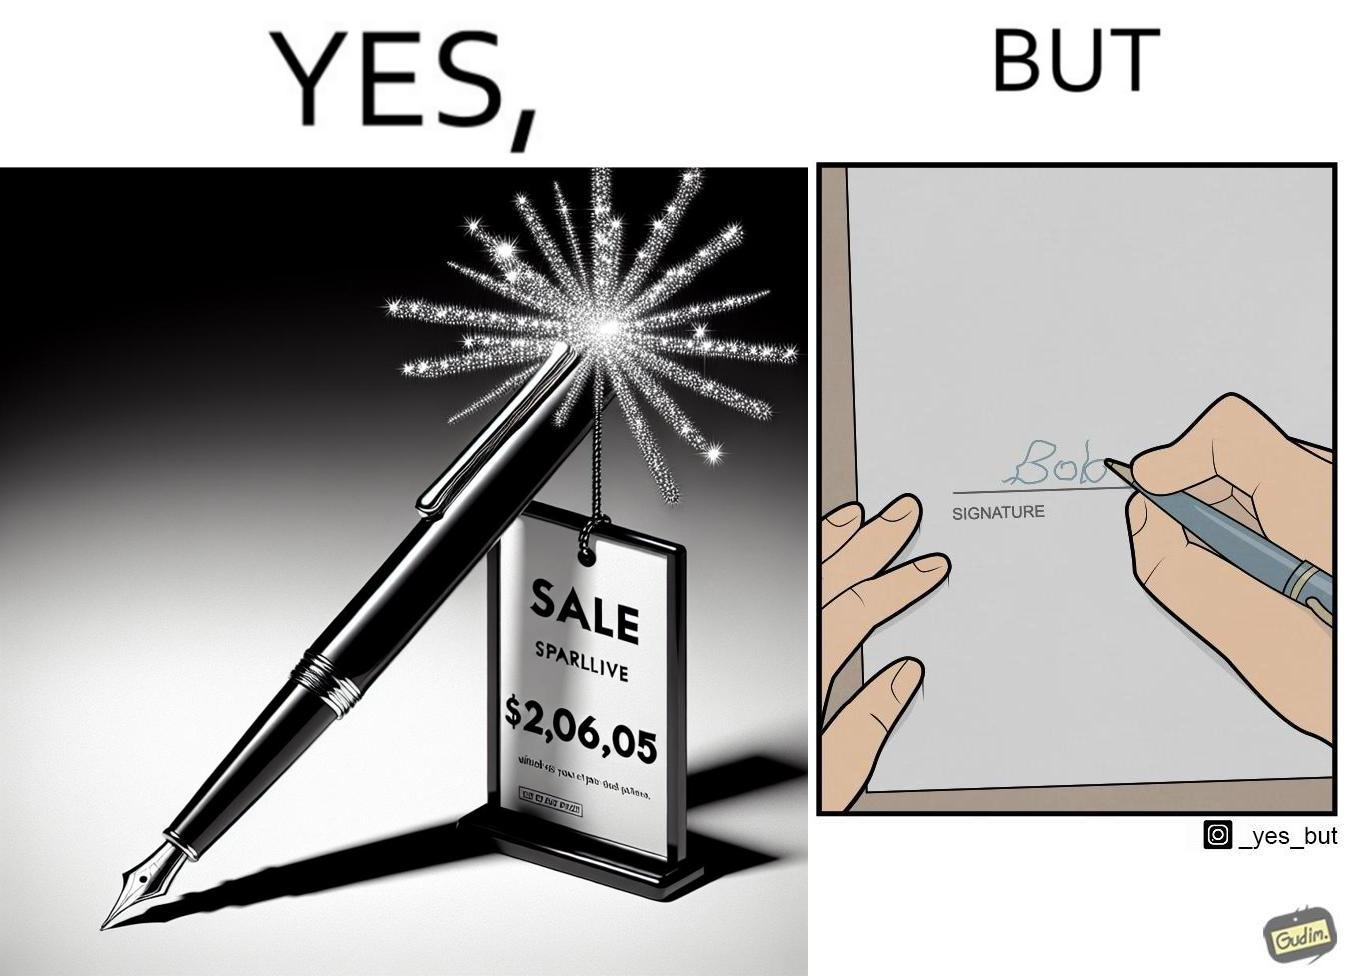Does this image contain satire or humor? Yes, this image is satirical. 